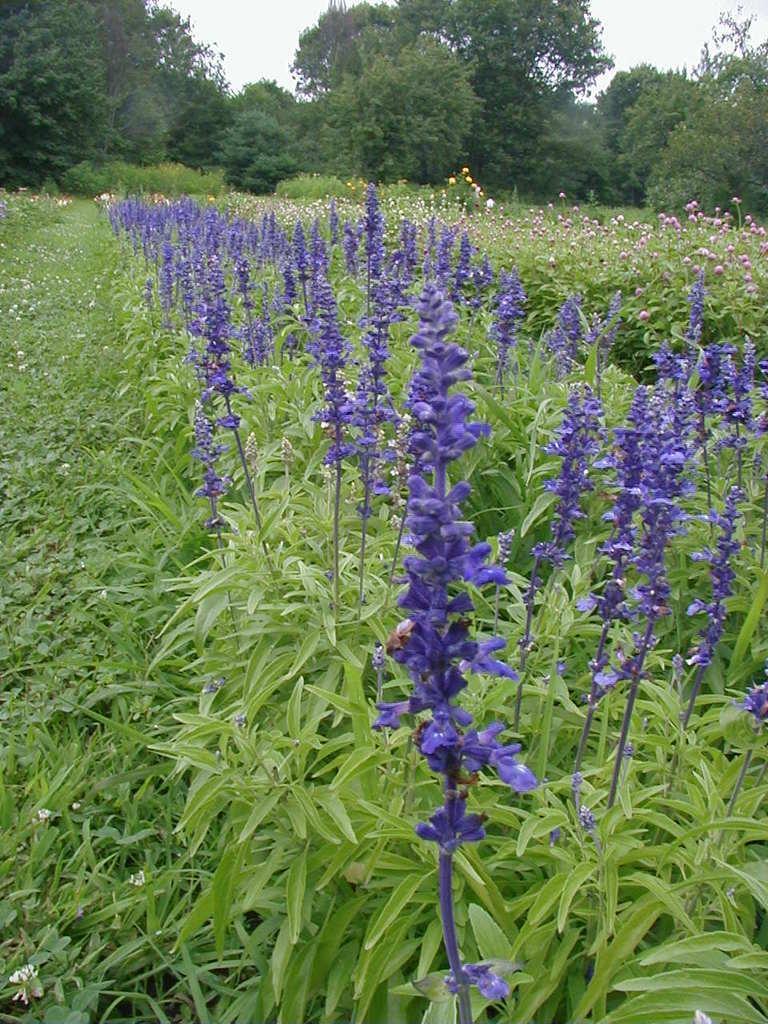How would you summarize this image in a sentence or two? In this image, we can see plants with flowers and in the background, there are trees. 